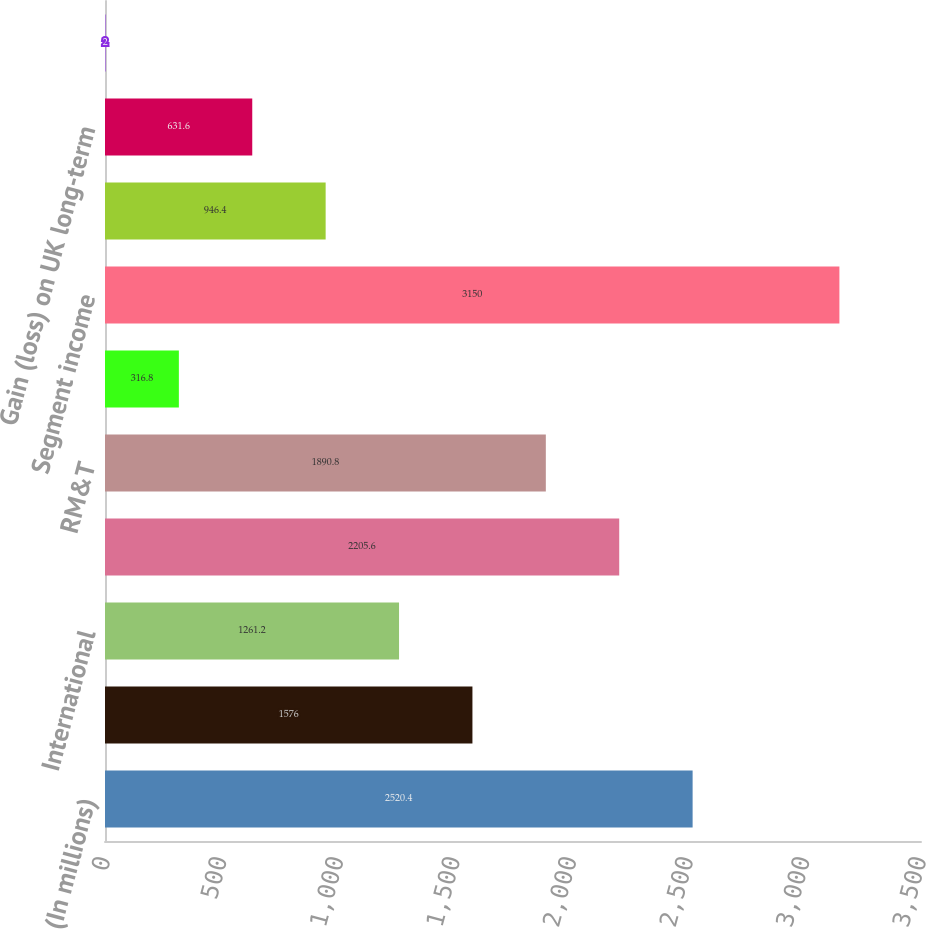Convert chart to OTSL. <chart><loc_0><loc_0><loc_500><loc_500><bar_chart><fcel>(In millions)<fcel>Domestic<fcel>International<fcel>E&P segment income<fcel>RM&T<fcel>IG<fcel>Segment income<fcel>Administrative expenses<fcel>Gain (loss) on UK long-term<fcel>Gain (loss) on ownership<nl><fcel>2520.4<fcel>1576<fcel>1261.2<fcel>2205.6<fcel>1890.8<fcel>316.8<fcel>3150<fcel>946.4<fcel>631.6<fcel>2<nl></chart> 